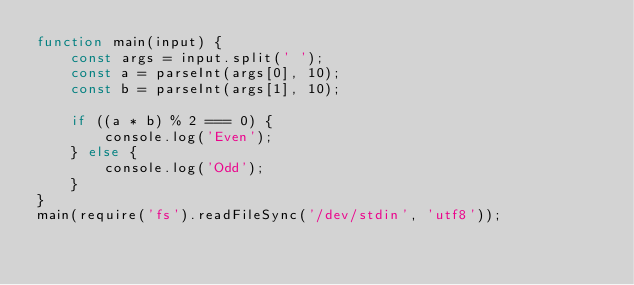<code> <loc_0><loc_0><loc_500><loc_500><_JavaScript_>function main(input) {
    const args = input.split(' ');
    const a = parseInt(args[0], 10);
    const b = parseInt(args[1], 10);

    if ((a * b) % 2 === 0) {
        console.log('Even');
    } else {
        console.log('Odd');
    }
}
main(require('fs').readFileSync('/dev/stdin', 'utf8'));</code> 